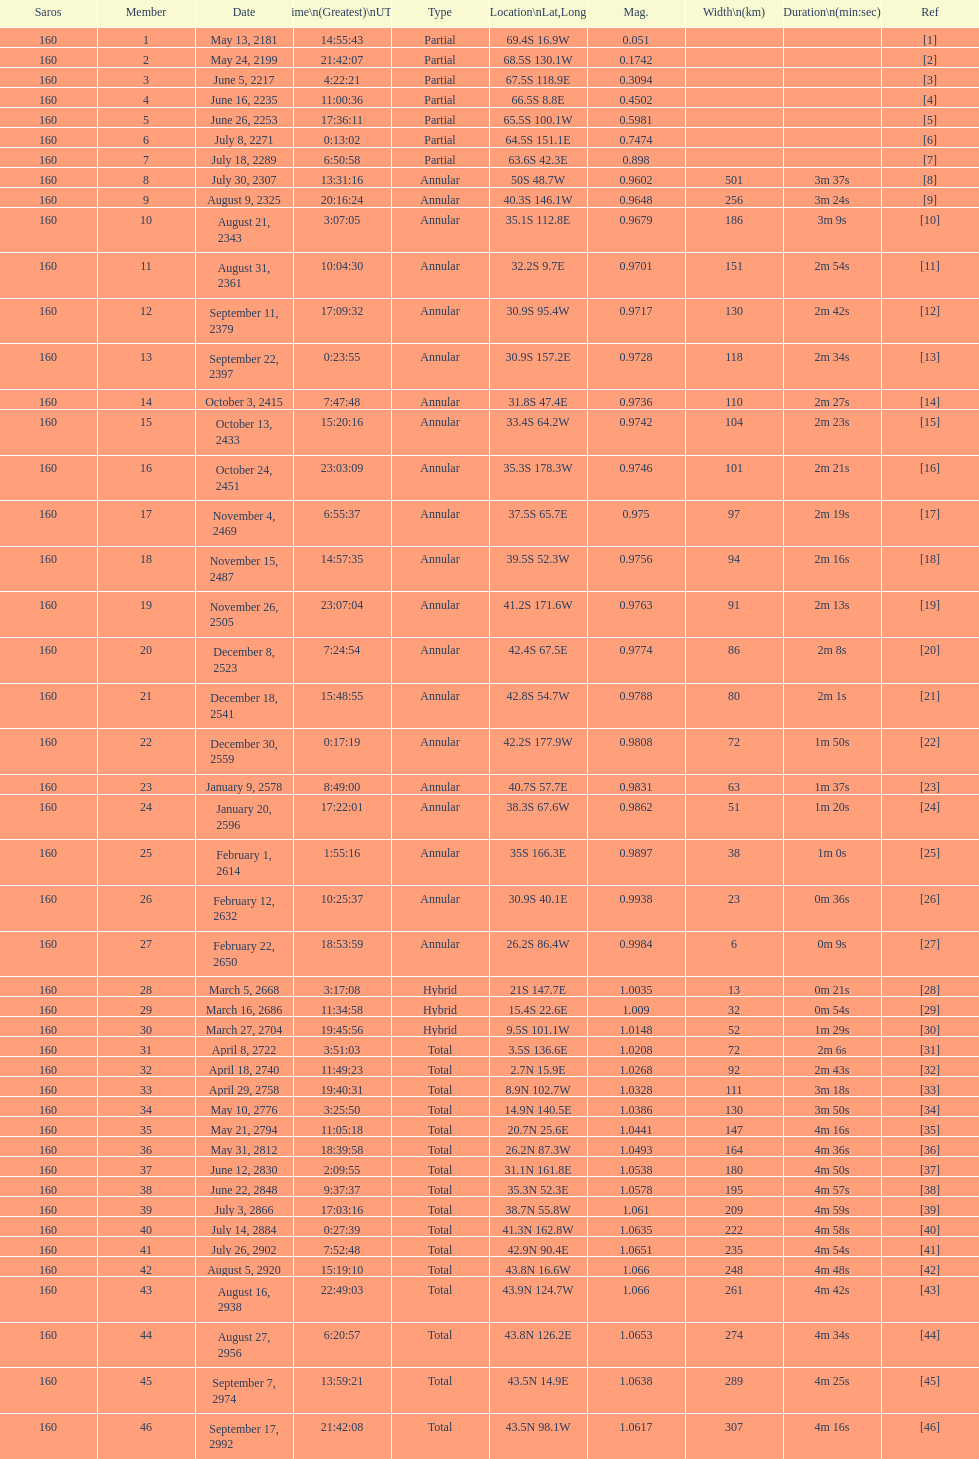When did the first solar saros with a magnitude of greater than 1.00 occur? March 5, 2668. Help me parse the entirety of this table. {'header': ['Saros', 'Member', 'Date', 'Time\\n(Greatest)\\nUTC', 'Type', 'Location\\nLat,Long', 'Mag.', 'Width\\n(km)', 'Duration\\n(min:sec)', 'Ref'], 'rows': [['160', '1', 'May 13, 2181', '14:55:43', 'Partial', '69.4S 16.9W', '0.051', '', '', '[1]'], ['160', '2', 'May 24, 2199', '21:42:07', 'Partial', '68.5S 130.1W', '0.1742', '', '', '[2]'], ['160', '3', 'June 5, 2217', '4:22:21', 'Partial', '67.5S 118.9E', '0.3094', '', '', '[3]'], ['160', '4', 'June 16, 2235', '11:00:36', 'Partial', '66.5S 8.8E', '0.4502', '', '', '[4]'], ['160', '5', 'June 26, 2253', '17:36:11', 'Partial', '65.5S 100.1W', '0.5981', '', '', '[5]'], ['160', '6', 'July 8, 2271', '0:13:02', 'Partial', '64.5S 151.1E', '0.7474', '', '', '[6]'], ['160', '7', 'July 18, 2289', '6:50:58', 'Partial', '63.6S 42.3E', '0.898', '', '', '[7]'], ['160', '8', 'July 30, 2307', '13:31:16', 'Annular', '50S 48.7W', '0.9602', '501', '3m 37s', '[8]'], ['160', '9', 'August 9, 2325', '20:16:24', 'Annular', '40.3S 146.1W', '0.9648', '256', '3m 24s', '[9]'], ['160', '10', 'August 21, 2343', '3:07:05', 'Annular', '35.1S 112.8E', '0.9679', '186', '3m 9s', '[10]'], ['160', '11', 'August 31, 2361', '10:04:30', 'Annular', '32.2S 9.7E', '0.9701', '151', '2m 54s', '[11]'], ['160', '12', 'September 11, 2379', '17:09:32', 'Annular', '30.9S 95.4W', '0.9717', '130', '2m 42s', '[12]'], ['160', '13', 'September 22, 2397', '0:23:55', 'Annular', '30.9S 157.2E', '0.9728', '118', '2m 34s', '[13]'], ['160', '14', 'October 3, 2415', '7:47:48', 'Annular', '31.8S 47.4E', '0.9736', '110', '2m 27s', '[14]'], ['160', '15', 'October 13, 2433', '15:20:16', 'Annular', '33.4S 64.2W', '0.9742', '104', '2m 23s', '[15]'], ['160', '16', 'October 24, 2451', '23:03:09', 'Annular', '35.3S 178.3W', '0.9746', '101', '2m 21s', '[16]'], ['160', '17', 'November 4, 2469', '6:55:37', 'Annular', '37.5S 65.7E', '0.975', '97', '2m 19s', '[17]'], ['160', '18', 'November 15, 2487', '14:57:35', 'Annular', '39.5S 52.3W', '0.9756', '94', '2m 16s', '[18]'], ['160', '19', 'November 26, 2505', '23:07:04', 'Annular', '41.2S 171.6W', '0.9763', '91', '2m 13s', '[19]'], ['160', '20', 'December 8, 2523', '7:24:54', 'Annular', '42.4S 67.5E', '0.9774', '86', '2m 8s', '[20]'], ['160', '21', 'December 18, 2541', '15:48:55', 'Annular', '42.8S 54.7W', '0.9788', '80', '2m 1s', '[21]'], ['160', '22', 'December 30, 2559', '0:17:19', 'Annular', '42.2S 177.9W', '0.9808', '72', '1m 50s', '[22]'], ['160', '23', 'January 9, 2578', '8:49:00', 'Annular', '40.7S 57.7E', '0.9831', '63', '1m 37s', '[23]'], ['160', '24', 'January 20, 2596', '17:22:01', 'Annular', '38.3S 67.6W', '0.9862', '51', '1m 20s', '[24]'], ['160', '25', 'February 1, 2614', '1:55:16', 'Annular', '35S 166.3E', '0.9897', '38', '1m 0s', '[25]'], ['160', '26', 'February 12, 2632', '10:25:37', 'Annular', '30.9S 40.1E', '0.9938', '23', '0m 36s', '[26]'], ['160', '27', 'February 22, 2650', '18:53:59', 'Annular', '26.2S 86.4W', '0.9984', '6', '0m 9s', '[27]'], ['160', '28', 'March 5, 2668', '3:17:08', 'Hybrid', '21S 147.7E', '1.0035', '13', '0m 21s', '[28]'], ['160', '29', 'March 16, 2686', '11:34:58', 'Hybrid', '15.4S 22.6E', '1.009', '32', '0m 54s', '[29]'], ['160', '30', 'March 27, 2704', '19:45:56', 'Hybrid', '9.5S 101.1W', '1.0148', '52', '1m 29s', '[30]'], ['160', '31', 'April 8, 2722', '3:51:03', 'Total', '3.5S 136.6E', '1.0208', '72', '2m 6s', '[31]'], ['160', '32', 'April 18, 2740', '11:49:23', 'Total', '2.7N 15.9E', '1.0268', '92', '2m 43s', '[32]'], ['160', '33', 'April 29, 2758', '19:40:31', 'Total', '8.9N 102.7W', '1.0328', '111', '3m 18s', '[33]'], ['160', '34', 'May 10, 2776', '3:25:50', 'Total', '14.9N 140.5E', '1.0386', '130', '3m 50s', '[34]'], ['160', '35', 'May 21, 2794', '11:05:18', 'Total', '20.7N 25.6E', '1.0441', '147', '4m 16s', '[35]'], ['160', '36', 'May 31, 2812', '18:39:58', 'Total', '26.2N 87.3W', '1.0493', '164', '4m 36s', '[36]'], ['160', '37', 'June 12, 2830', '2:09:55', 'Total', '31.1N 161.8E', '1.0538', '180', '4m 50s', '[37]'], ['160', '38', 'June 22, 2848', '9:37:37', 'Total', '35.3N 52.3E', '1.0578', '195', '4m 57s', '[38]'], ['160', '39', 'July 3, 2866', '17:03:16', 'Total', '38.7N 55.8W', '1.061', '209', '4m 59s', '[39]'], ['160', '40', 'July 14, 2884', '0:27:39', 'Total', '41.3N 162.8W', '1.0635', '222', '4m 58s', '[40]'], ['160', '41', 'July 26, 2902', '7:52:48', 'Total', '42.9N 90.4E', '1.0651', '235', '4m 54s', '[41]'], ['160', '42', 'August 5, 2920', '15:19:10', 'Total', '43.8N 16.6W', '1.066', '248', '4m 48s', '[42]'], ['160', '43', 'August 16, 2938', '22:49:03', 'Total', '43.9N 124.7W', '1.066', '261', '4m 42s', '[43]'], ['160', '44', 'August 27, 2956', '6:20:57', 'Total', '43.8N 126.2E', '1.0653', '274', '4m 34s', '[44]'], ['160', '45', 'September 7, 2974', '13:59:21', 'Total', '43.5N 14.9E', '1.0638', '289', '4m 25s', '[45]'], ['160', '46', 'September 17, 2992', '21:42:08', 'Total', '43.5N 98.1W', '1.0617', '307', '4m 16s', '[46]']]} 